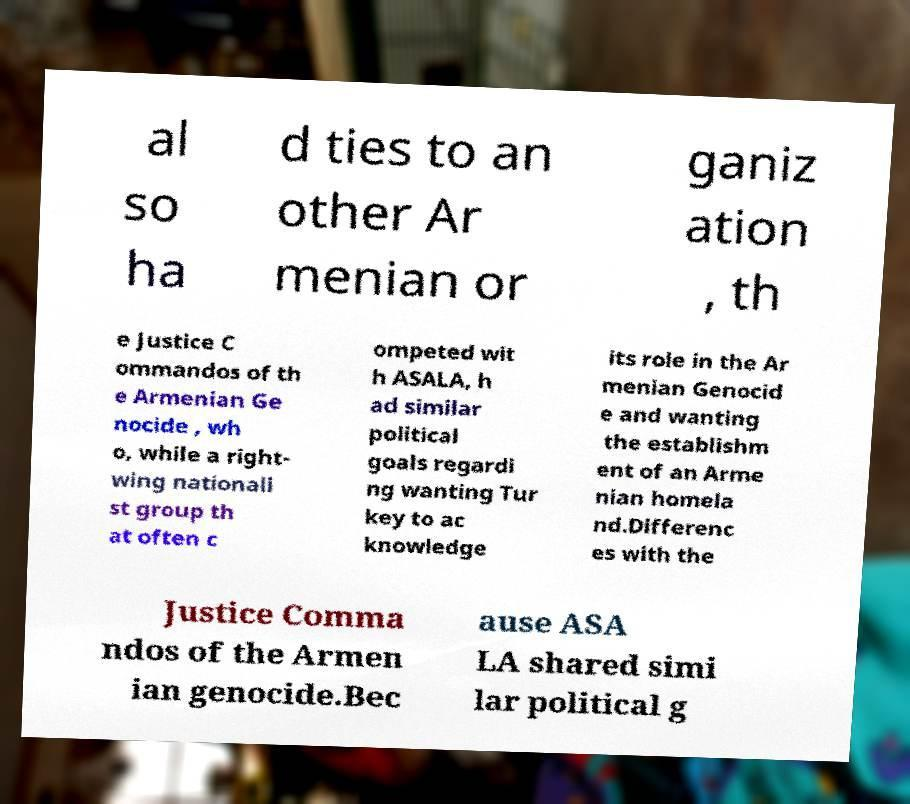Can you accurately transcribe the text from the provided image for me? al so ha d ties to an other Ar menian or ganiz ation , th e Justice C ommandos of th e Armenian Ge nocide , wh o, while a right- wing nationali st group th at often c ompeted wit h ASALA, h ad similar political goals regardi ng wanting Tur key to ac knowledge its role in the Ar menian Genocid e and wanting the establishm ent of an Arme nian homela nd.Differenc es with the Justice Comma ndos of the Armen ian genocide.Bec ause ASA LA shared simi lar political g 